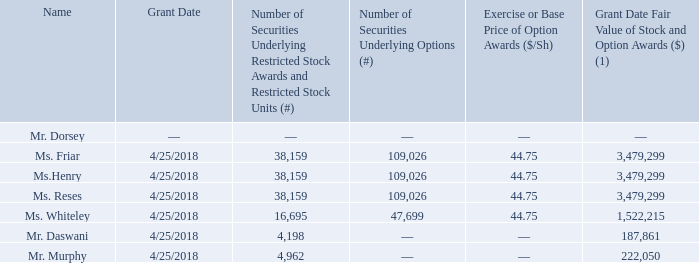Grants of Plan-Based Awards in 2018
The following table sets forth information regarding grants of awards made to our named executive officers during 2018. We did not grant any plan-based cash awards during 2018.
(1) The amounts included in this column represent the aggregate grant date fair value of RSUs, RSAs and option awards calculated in accordance with ASC 718. The valuation assumptions used in determining the grant date fair value of the RSUs, RSAs and options reported in this column are described in the Notes to the Consolidated Financial Statements included in our Annual Report on Form 10-K for the fiscal year ended December 31, 2018.
What does the table show? Information regarding grants of awards made to our named executive officers during 2018. What does the column “Grant Date Fair Value of Stock and Option Awards” represent? The aggregate grant date fair value of rsus, rsas and option awards calculated in accordance with asc 718. When is the Grant Date for all the executive officers? 4/25/2018. What is the difference between the smallest and largest amount of Grant Date Fair Value of Stock and Option Awards? 3,479,299 - 187,861
Answer: 3291438. What is the average Number of Securities Underlying Restricted Stock Awards and Restricted Stock Units for those who received it? (38,159 + 38,159 + 38,159 + 16,695 + 4,198 + 4,962) / 6 
Answer: 23388.67. What is the ratio of Ms. Henry’s to Ms. Whiteley’s Number of Securities Underlying Options? 109,026 / 47,699 
Answer: 2.29. 